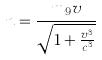Convert formula to latex. <formula><loc_0><loc_0><loc_500><loc_500>n = \frac { m _ { 9 } v } { \sqrt { 1 + \frac { v ^ { 3 } } { c ^ { 3 } } } }</formula> 